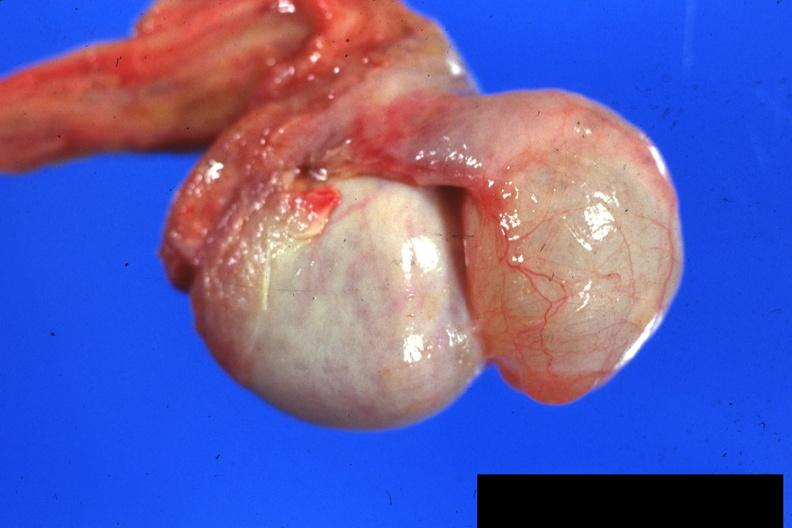s 70yof present?
Answer the question using a single word or phrase. No 